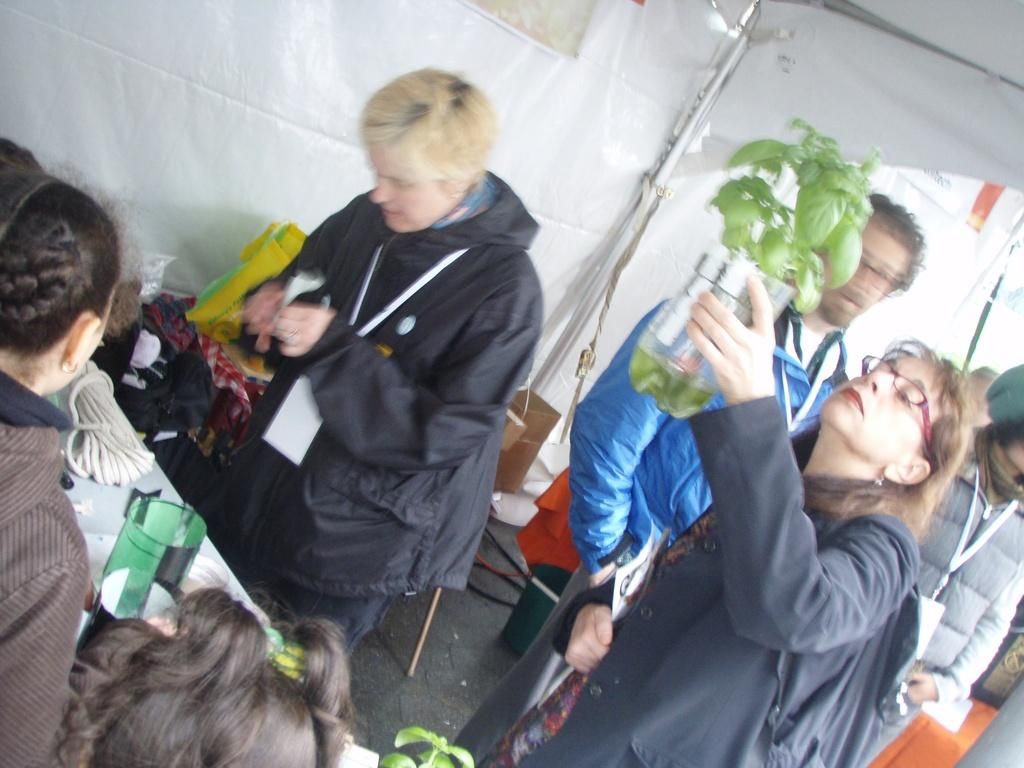How many people are in the image? There is a group of people in the image. What is the position of the people in the image? The people are on the floor. What type of furniture is present in the image? There are chairs and tables in the image. What items can be seen that might be used for carrying or storing things? There are bags in the image. What type of material is present in the image that might be used for tying or securing objects? There are ropes in the image. What type of objects can be seen in the image? There are some objects in the image. What type of plant is present in the image? There is a houseplant in the image. What type of shelter is present in the image? There is a tent in the image. What can be inferred about the time of day when the image was taken? The image was likely taken during the day. What type of tray is used to make the discovery in the image? There is no tray or discovery present in the image. What type of spark can be seen coming from the houseplant in the image? There is no spark present in the image; it is a houseplant. 